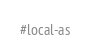<code> <loc_0><loc_0><loc_500><loc_500><_Python_>#local-as
</code> 